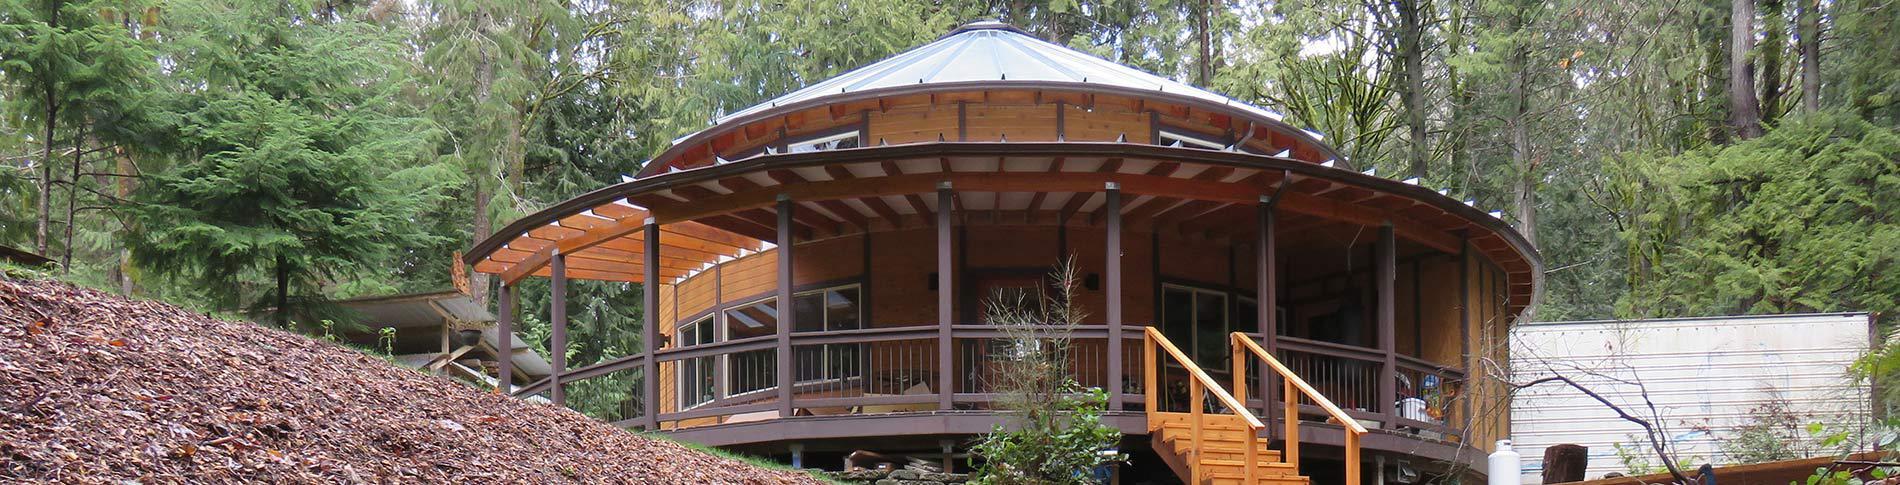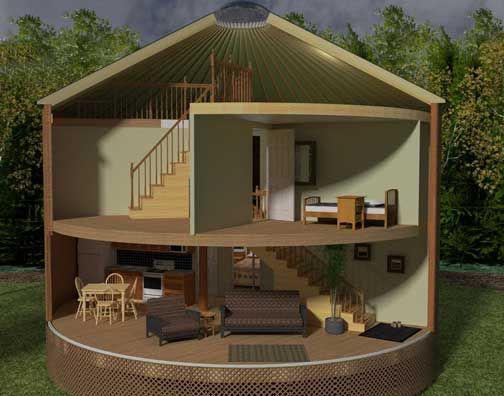The first image is the image on the left, the second image is the image on the right. For the images shown, is this caption "At least one house has no visible windows." true? Answer yes or no. Yes. 